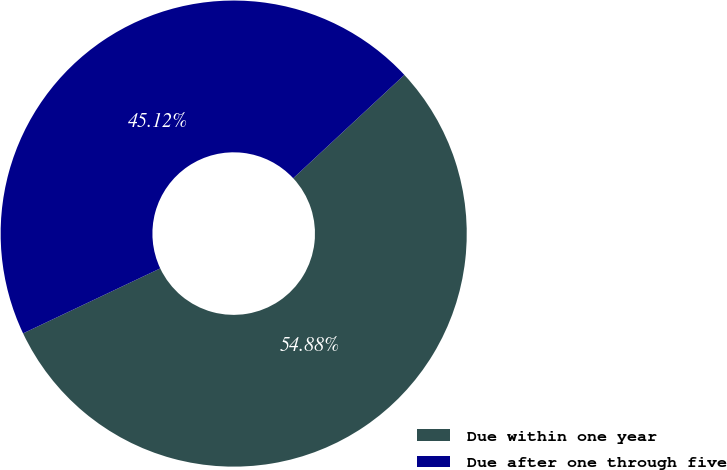Convert chart. <chart><loc_0><loc_0><loc_500><loc_500><pie_chart><fcel>Due within one year<fcel>Due after one through five<nl><fcel>54.88%<fcel>45.12%<nl></chart> 